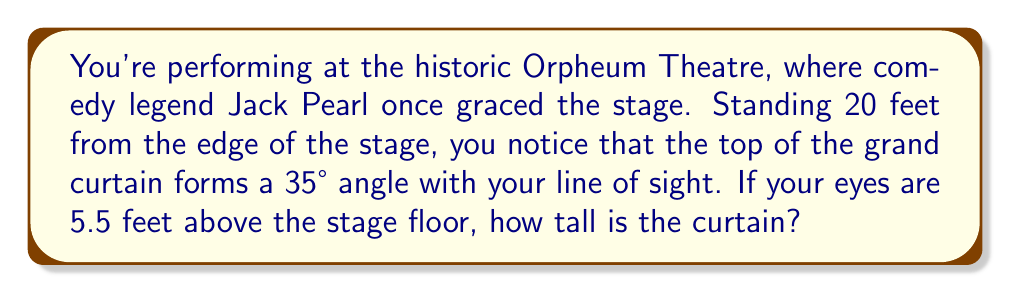What is the answer to this math problem? Let's approach this step-by-step:

1) First, let's visualize the problem:

[asy]
import geometry;

unitsize(0.2 cm);

pair A = (0,0), B = (20,0), C = (20,35), D = (0,5.5);
draw(A--B--C--D--A);
draw(D--C, dashed);

label("Stage", (10,-2));
label("You", A, SW);
label("Curtain", C, E);
label("20 ft", (10,0), S);
label("5.5 ft", (-1,2.75), W);
label("35°", (1,1), NW);
label("h", (21,17.5), E);

dot("A", A, SW);
dot("B", B, SE);
dot("C", C, E);
dot("D", D, NW);
[/asy]

2) We can see that this forms a right triangle, where:
   - The base of the triangle is 20 feet (distance from you to the stage)
   - Your eye level is 5.5 feet above the stage
   - The angle between your line of sight and the floor is 35°
   - We need to find the height of the curtain (h) minus your eye level

3) We can use the tangent ratio to solve this:

   $$\tan(\theta) = \frac{\text{opposite}}{\text{adjacent}}$$

4) In our case:
   $$\tan(35°) = \frac{h - 5.5}{20}$$

5) Solving for h:
   $$h - 5.5 = 20 \tan(35°)$$
   $$h = 20 \tan(35°) + 5.5$$

6) Now let's calculate:
   $$h = 20 \cdot 0.7002 + 5.5$$
   $$h = 14.004 + 5.5 = 19.504$$

7) Rounding to the nearest inch:
   $$h \approx 19.5 \text{ feet}$$
Answer: 19.5 feet 